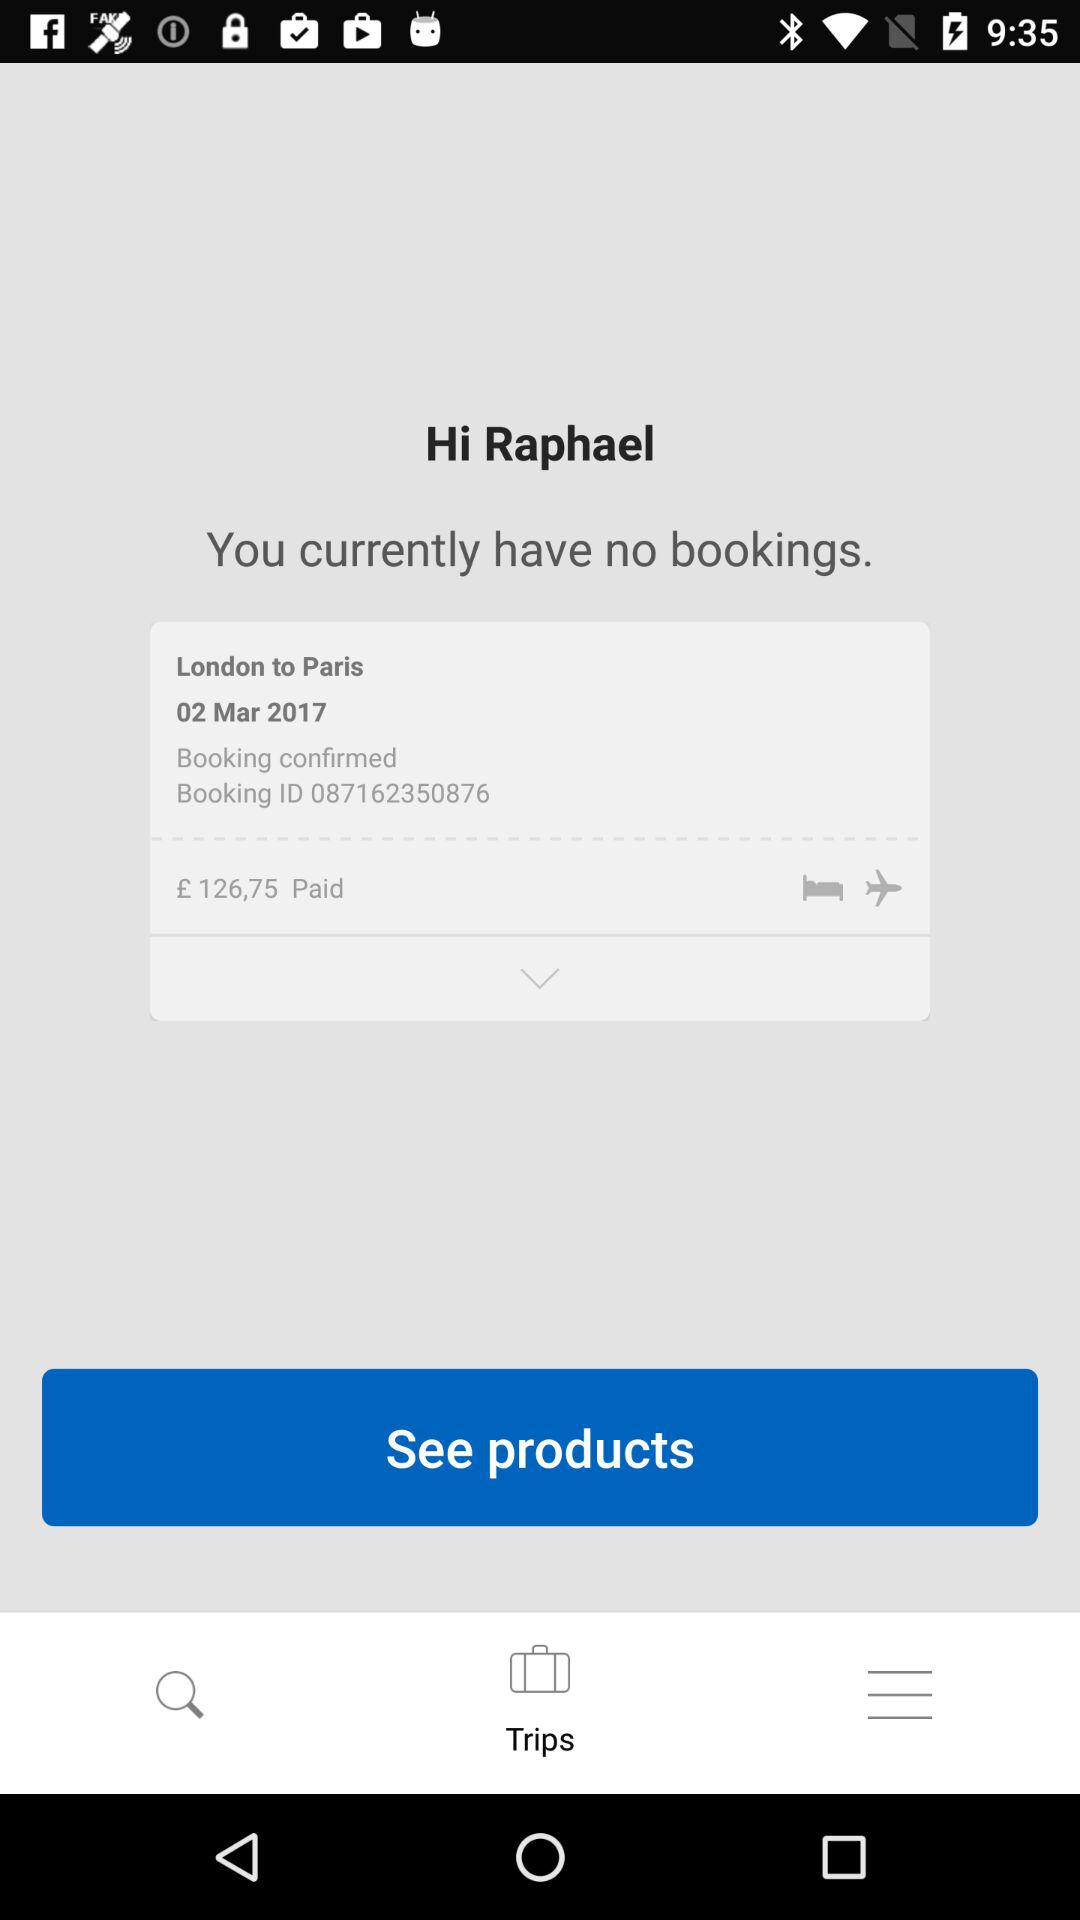What was the departure place? The departure place was London. 